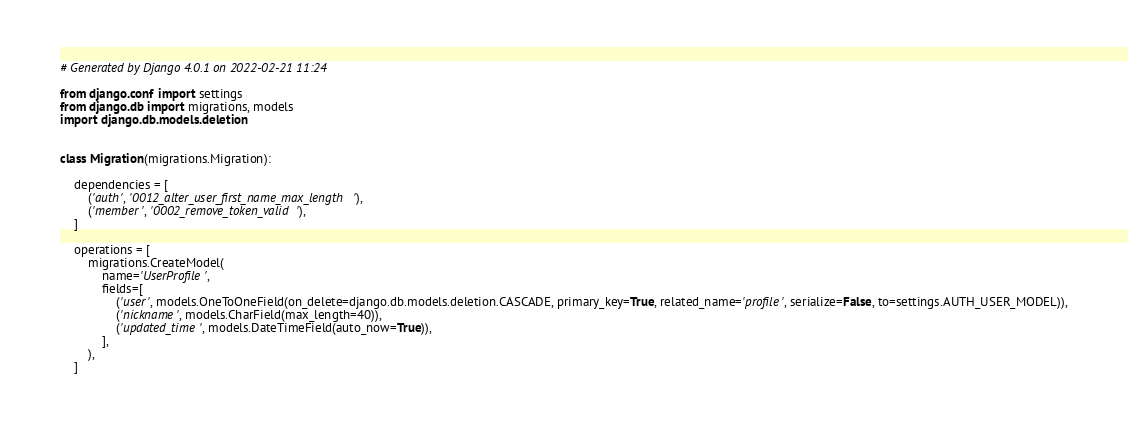<code> <loc_0><loc_0><loc_500><loc_500><_Python_># Generated by Django 4.0.1 on 2022-02-21 11:24

from django.conf import settings
from django.db import migrations, models
import django.db.models.deletion


class Migration(migrations.Migration):

    dependencies = [
        ('auth', '0012_alter_user_first_name_max_length'),
        ('member', '0002_remove_token_valid'),
    ]

    operations = [
        migrations.CreateModel(
            name='UserProfile',
            fields=[
                ('user', models.OneToOneField(on_delete=django.db.models.deletion.CASCADE, primary_key=True, related_name='profile', serialize=False, to=settings.AUTH_USER_MODEL)),
                ('nickname', models.CharField(max_length=40)),
                ('updated_time', models.DateTimeField(auto_now=True)),
            ],
        ),
    ]
</code> 